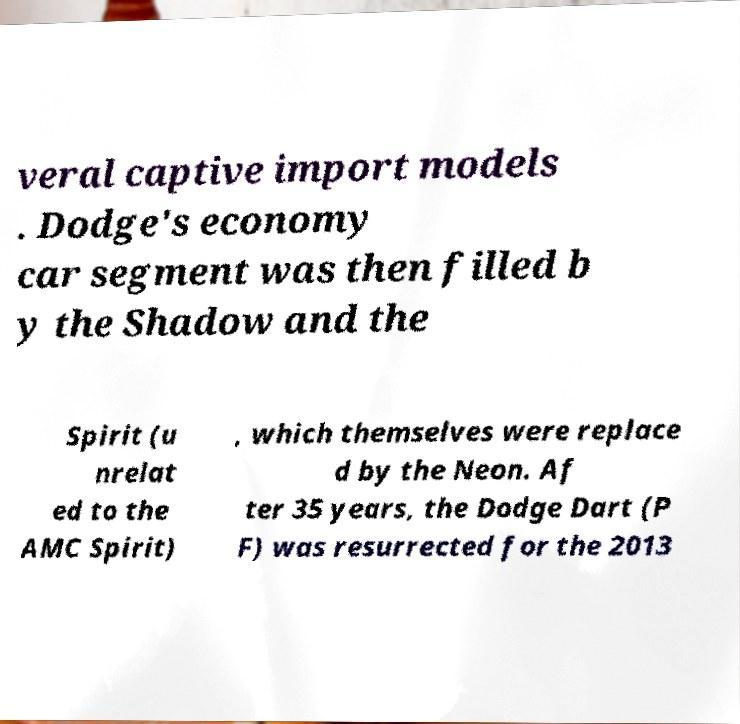For documentation purposes, I need the text within this image transcribed. Could you provide that? veral captive import models . Dodge's economy car segment was then filled b y the Shadow and the Spirit (u nrelat ed to the AMC Spirit) , which themselves were replace d by the Neon. Af ter 35 years, the Dodge Dart (P F) was resurrected for the 2013 